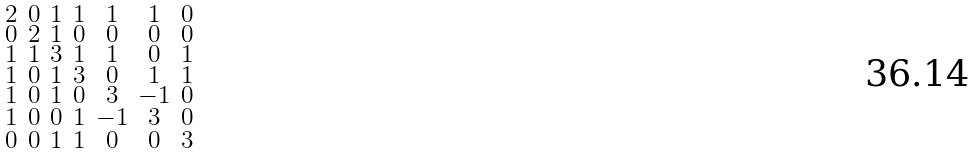<formula> <loc_0><loc_0><loc_500><loc_500>\begin{smallmatrix} 2 & 0 & 1 & 1 & 1 & 1 & 0 \\ 0 & 2 & 1 & 0 & 0 & 0 & 0 \\ 1 & 1 & 3 & 1 & 1 & 0 & 1 \\ 1 & 0 & 1 & 3 & 0 & 1 & 1 \\ 1 & 0 & 1 & 0 & 3 & - 1 & 0 \\ 1 & 0 & 0 & 1 & - 1 & 3 & 0 \\ 0 & 0 & 1 & 1 & 0 & 0 & 3 \end{smallmatrix}</formula> 